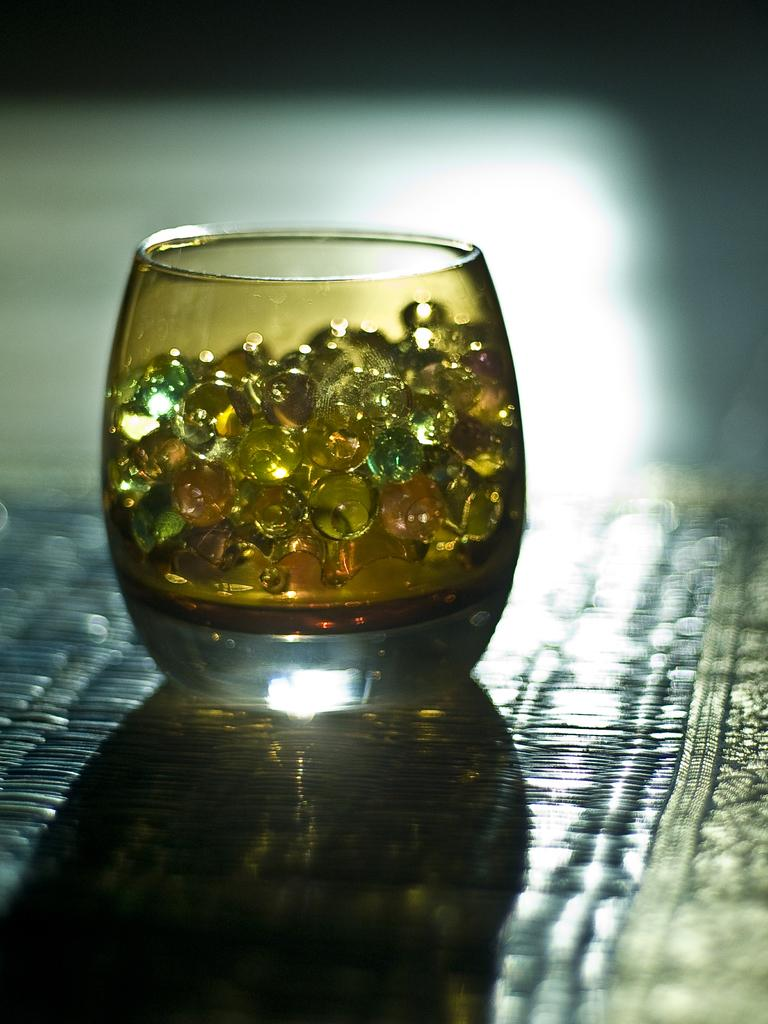What object is present in the image that can hold liquid? There is a glass in the image. What is inside the glass? The glass contains marbles. Can you describe any additional visual elements in the image? There is a shadow visible in the image. What type of fact can be seen in the image? There is no fact present in the image; it contains a glass with marbles and a shadow. Is there a spring visible in the image? There is no spring present in the image. 